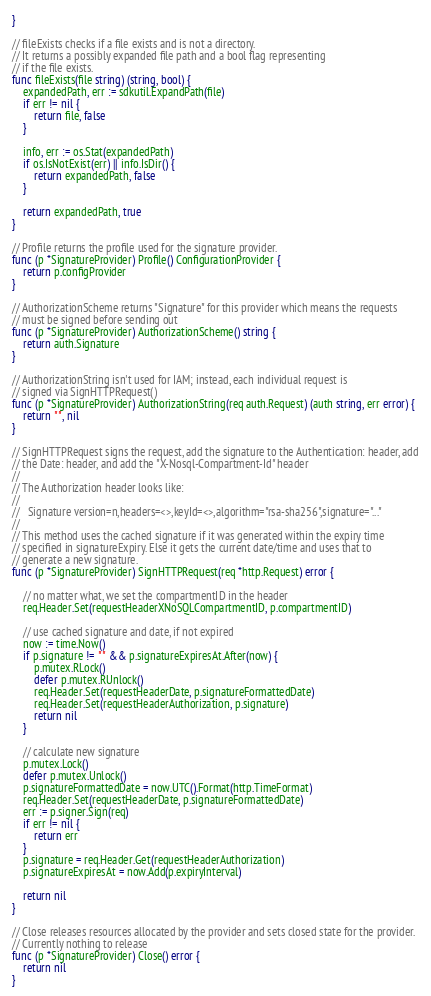<code> <loc_0><loc_0><loc_500><loc_500><_Go_>}

// fileExists checks if a file exists and is not a directory.
// It returns a possibly expanded file path and a bool flag representing
// if the file exists.
func fileExists(file string) (string, bool) {
	expandedPath, err := sdkutil.ExpandPath(file)
	if err != nil {
		return file, false
	}

	info, err := os.Stat(expandedPath)
	if os.IsNotExist(err) || info.IsDir() {
		return expandedPath, false
	}

	return expandedPath, true
}

// Profile returns the profile used for the signature provider.
func (p *SignatureProvider) Profile() ConfigurationProvider {
	return p.configProvider
}

// AuthorizationScheme returns "Signature" for this provider which means the requests
// must be signed before sending out
func (p *SignatureProvider) AuthorizationScheme() string {
	return auth.Signature
}

// AuthorizationString isn't used for IAM; instead, each individual request is
// signed via SignHTTPRequest()
func (p *SignatureProvider) AuthorizationString(req auth.Request) (auth string, err error) {
	return "", nil
}

// SignHTTPRequest signs the request, add the signature to the Authentication: header, add
// the Date: header, and add the "X-Nosql-Compartment-Id" header
//
// The Authorization header looks like:
//
//   Signature version=n,headers=<>,keyId=<>,algorithm="rsa-sha256",signature="..."
//
// This method uses the cached signature if it was generated within the expiry time
// specified in signatureExpiry. Else it gets the current date/time and uses that to
// generate a new signature.
func (p *SignatureProvider) SignHTTPRequest(req *http.Request) error {

	// no matter what, we set the compartmentID in the header
	req.Header.Set(requestHeaderXNoSQLCompartmentID, p.compartmentID)

	// use cached signature and date, if not expired
	now := time.Now()
	if p.signature != "" && p.signatureExpiresAt.After(now) {
		p.mutex.RLock()
		defer p.mutex.RUnlock()
		req.Header.Set(requestHeaderDate, p.signatureFormattedDate)
		req.Header.Set(requestHeaderAuthorization, p.signature)
		return nil
	}

	// calculate new signature
	p.mutex.Lock()
	defer p.mutex.Unlock()
	p.signatureFormattedDate = now.UTC().Format(http.TimeFormat)
	req.Header.Set(requestHeaderDate, p.signatureFormattedDate)
	err := p.signer.Sign(req)
	if err != nil {
		return err
	}
	p.signature = req.Header.Get(requestHeaderAuthorization)
	p.signatureExpiresAt = now.Add(p.expiryInterval)

	return nil
}

// Close releases resources allocated by the provider and sets closed state for the provider.
// Currently nothing to release
func (p *SignatureProvider) Close() error {
	return nil
}
</code> 